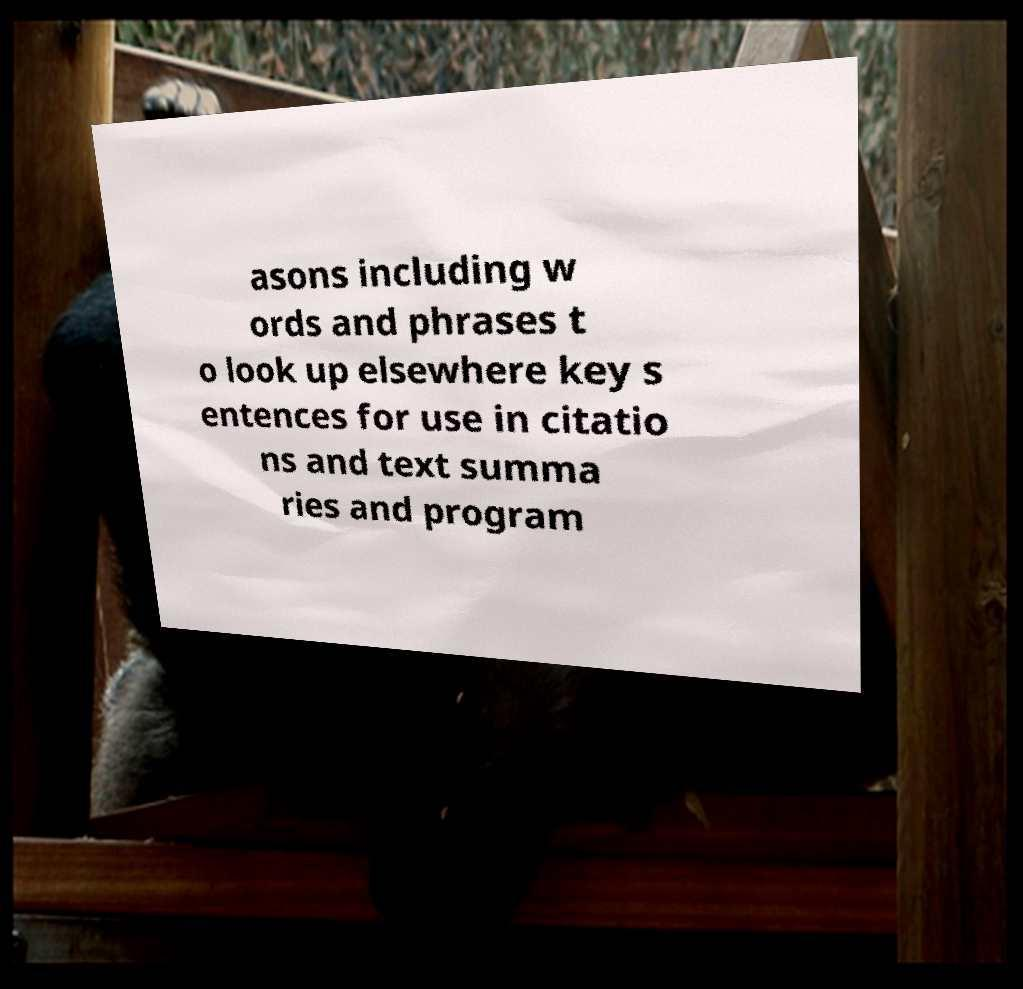Can you read and provide the text displayed in the image?This photo seems to have some interesting text. Can you extract and type it out for me? asons including w ords and phrases t o look up elsewhere key s entences for use in citatio ns and text summa ries and program 